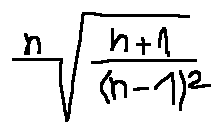Convert formula to latex. <formula><loc_0><loc_0><loc_500><loc_500>\sqrt { [ } n ] { \frac { n + 1 } { ( n - 1 ) ^ { 2 } } }</formula> 